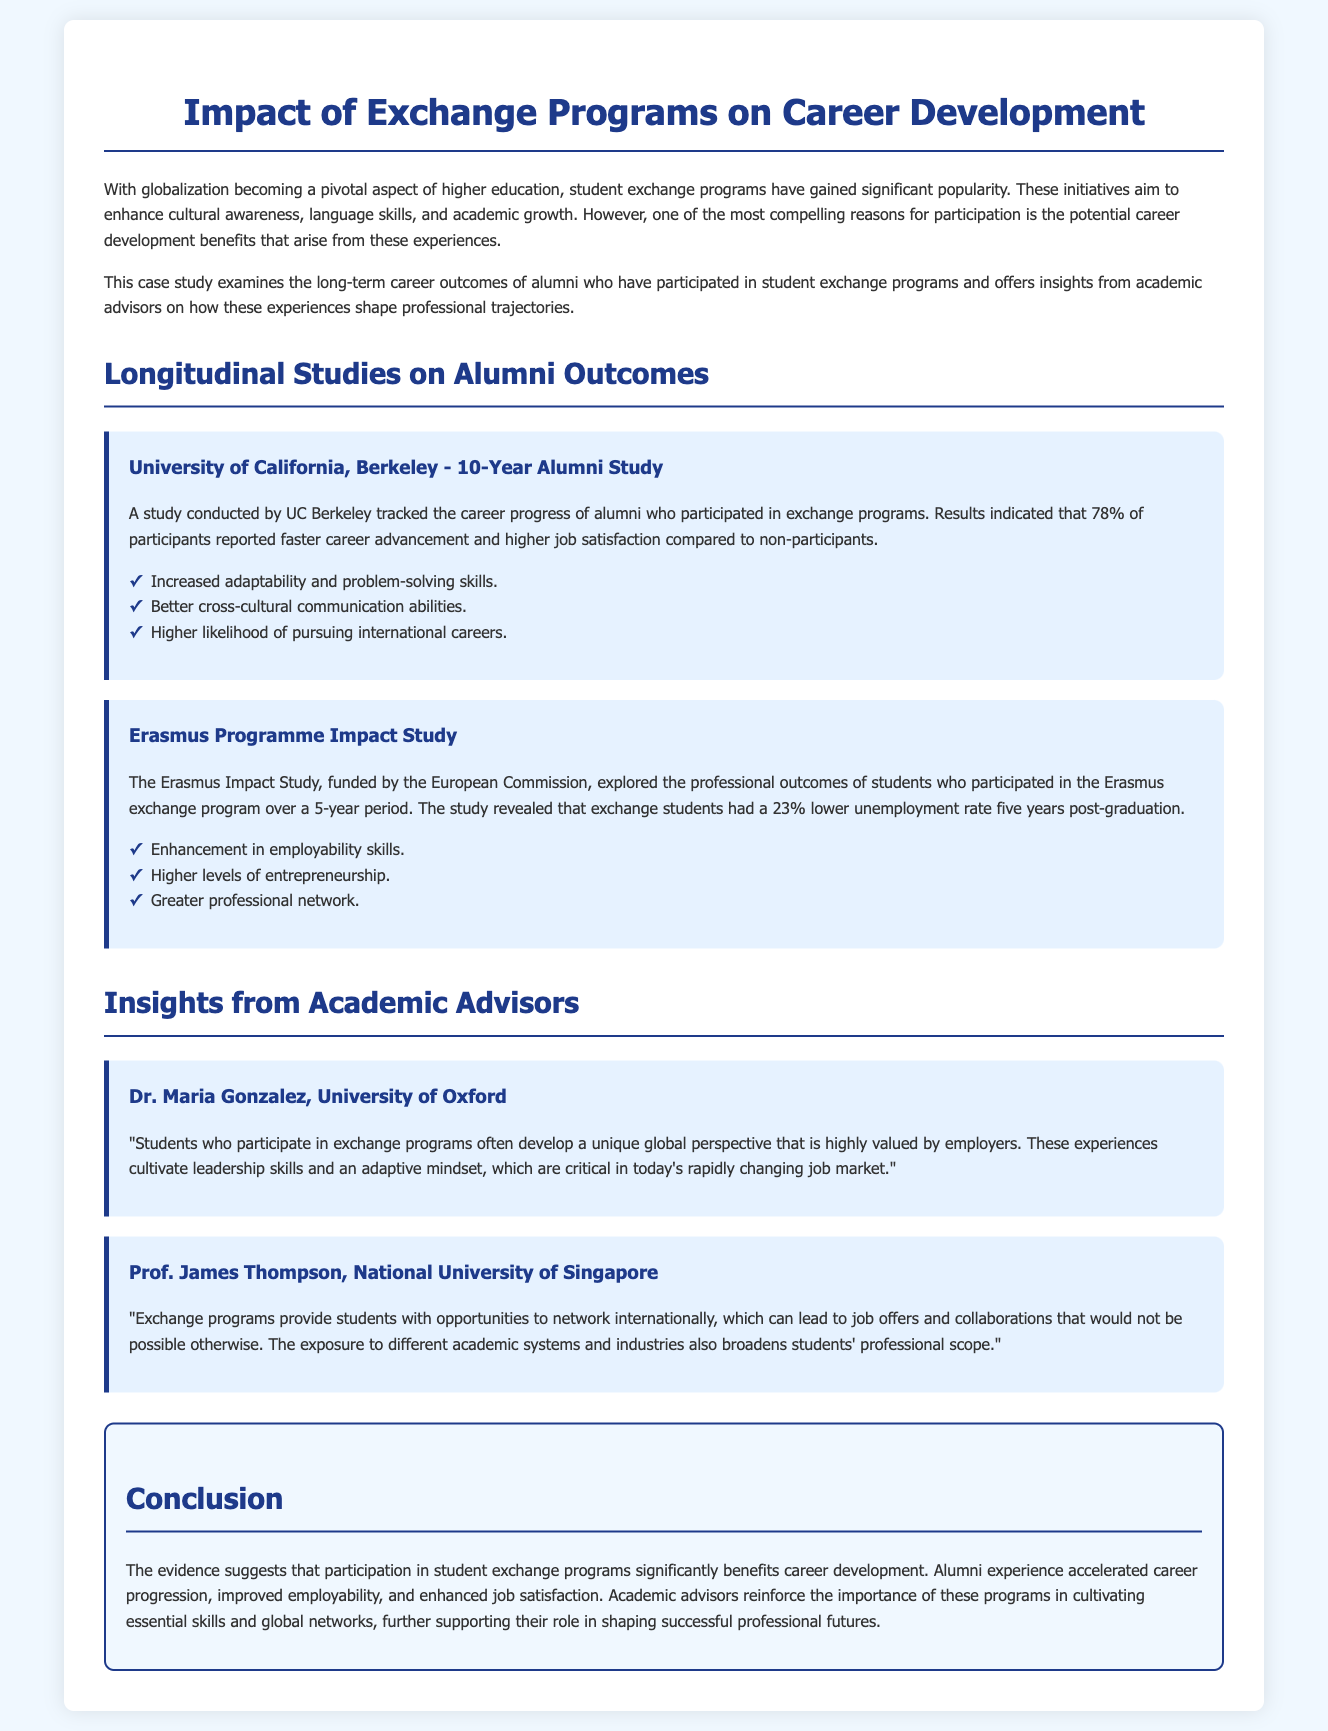What is the title of the case study? The title of the case study is prominently displayed at the top of the document.
Answer: Impact of Exchange Programs on Career Development What percentage of participants reported faster career advancement at UC Berkeley? The document states specific percentages related to outcomes from UC Berkeley's study, highlighting participant experiences.
Answer: 78% What is the unemployment rate reduction for Erasmus participants five years post-graduation? The Erasmus Impact Study provides specific statistics regarding unemployment rates post-graduation for participants.
Answer: 23% Who conducted the 10-Year Alumni Study? The document identifies the institution responsible for conducting the alumni study.
Answer: University of California, Berkeley What skills are enhanced through exchange programs according to academic advisors? The document discusses various skills that are cultivated through participation in exchange programs, mentioned by academic advisors.
Answer: Leadership skills Which institution's advisor emphasized the importance of networking through exchange programs? The document provides insights from multiple academic advisors, identifying their affiliations.
Answer: National University of Singapore What is the overall conclusion regarding exchange programs' impact on career development? The conclusion section summarizes the overall findings regarding the effects of exchange programs on alumni.
Answer: Significantly benefits career development Which academic advisor mentioned "unique global perspective"? The document quotes specific academic advisors and their insights, identifying key phrases they used.
Answer: Dr. Maria Gonzalez What is the primary purpose of student exchange programs discussed in the case study? The document outlines the main objectives of student exchange programs at the beginning.
Answer: Enhance cultural awareness 